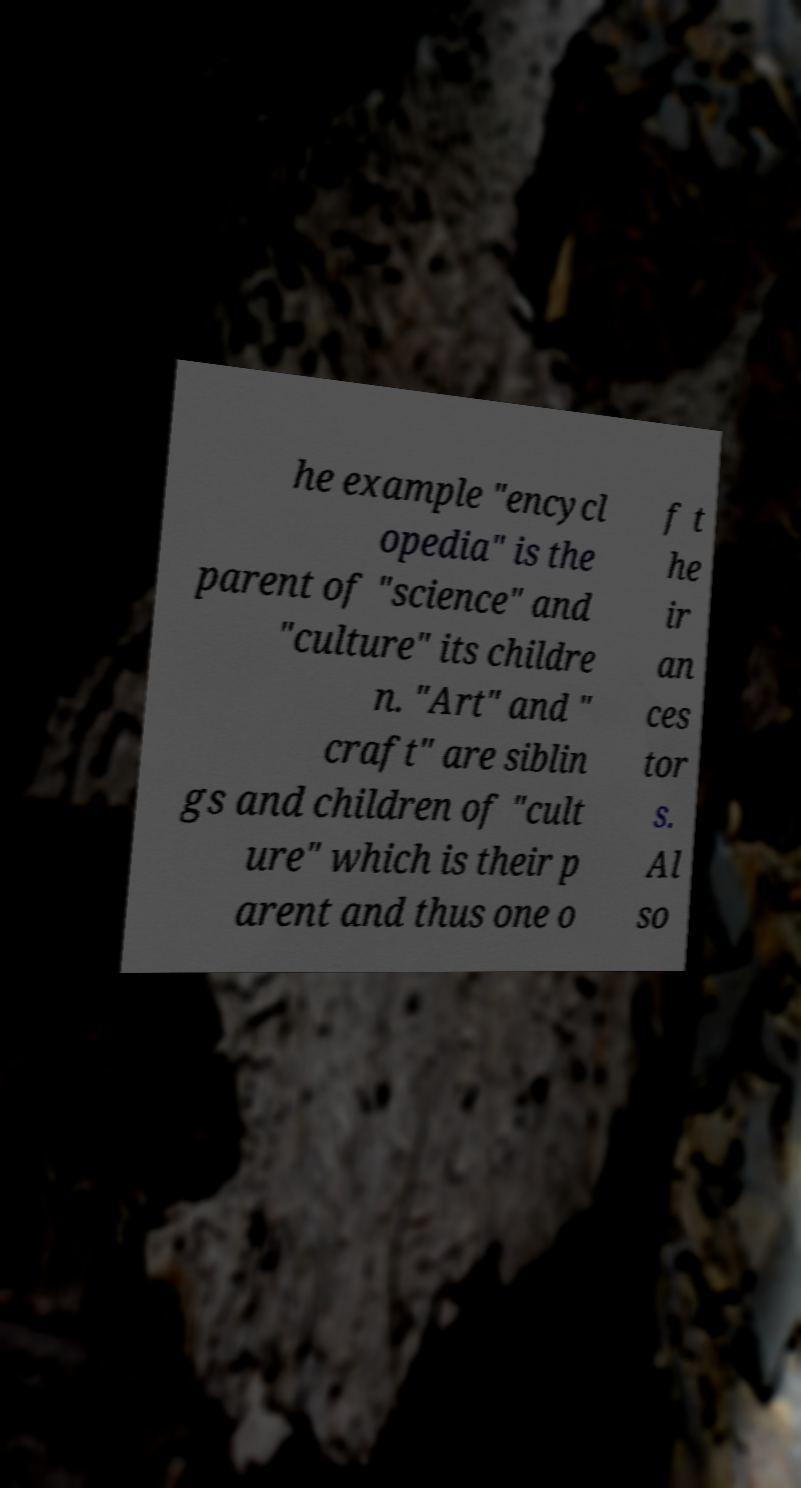Could you assist in decoding the text presented in this image and type it out clearly? he example "encycl opedia" is the parent of "science" and "culture" its childre n. "Art" and " craft" are siblin gs and children of "cult ure" which is their p arent and thus one o f t he ir an ces tor s. Al so 